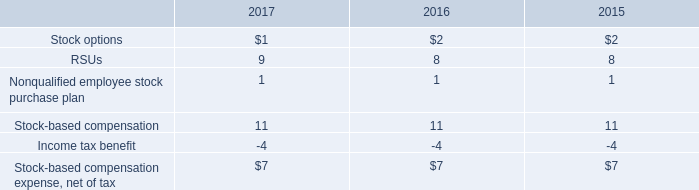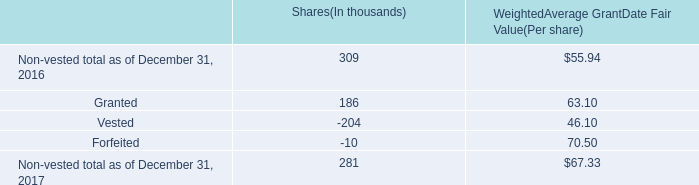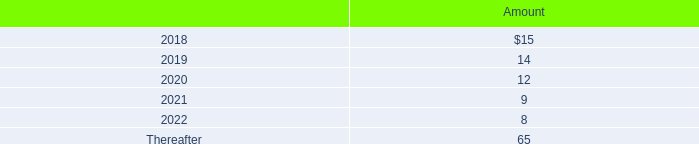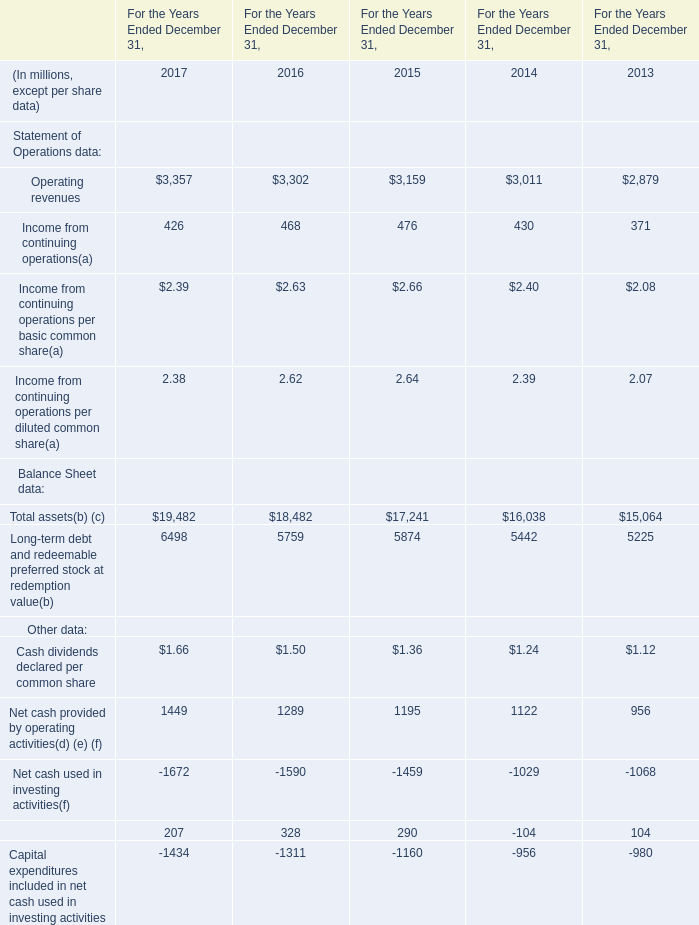based on the weighted average grant date fair value ( per share ) , what was the total granted rsu cost during 2017? 
Computations: ((186 * 1000) * 63.10)
Answer: 11736600.0. 